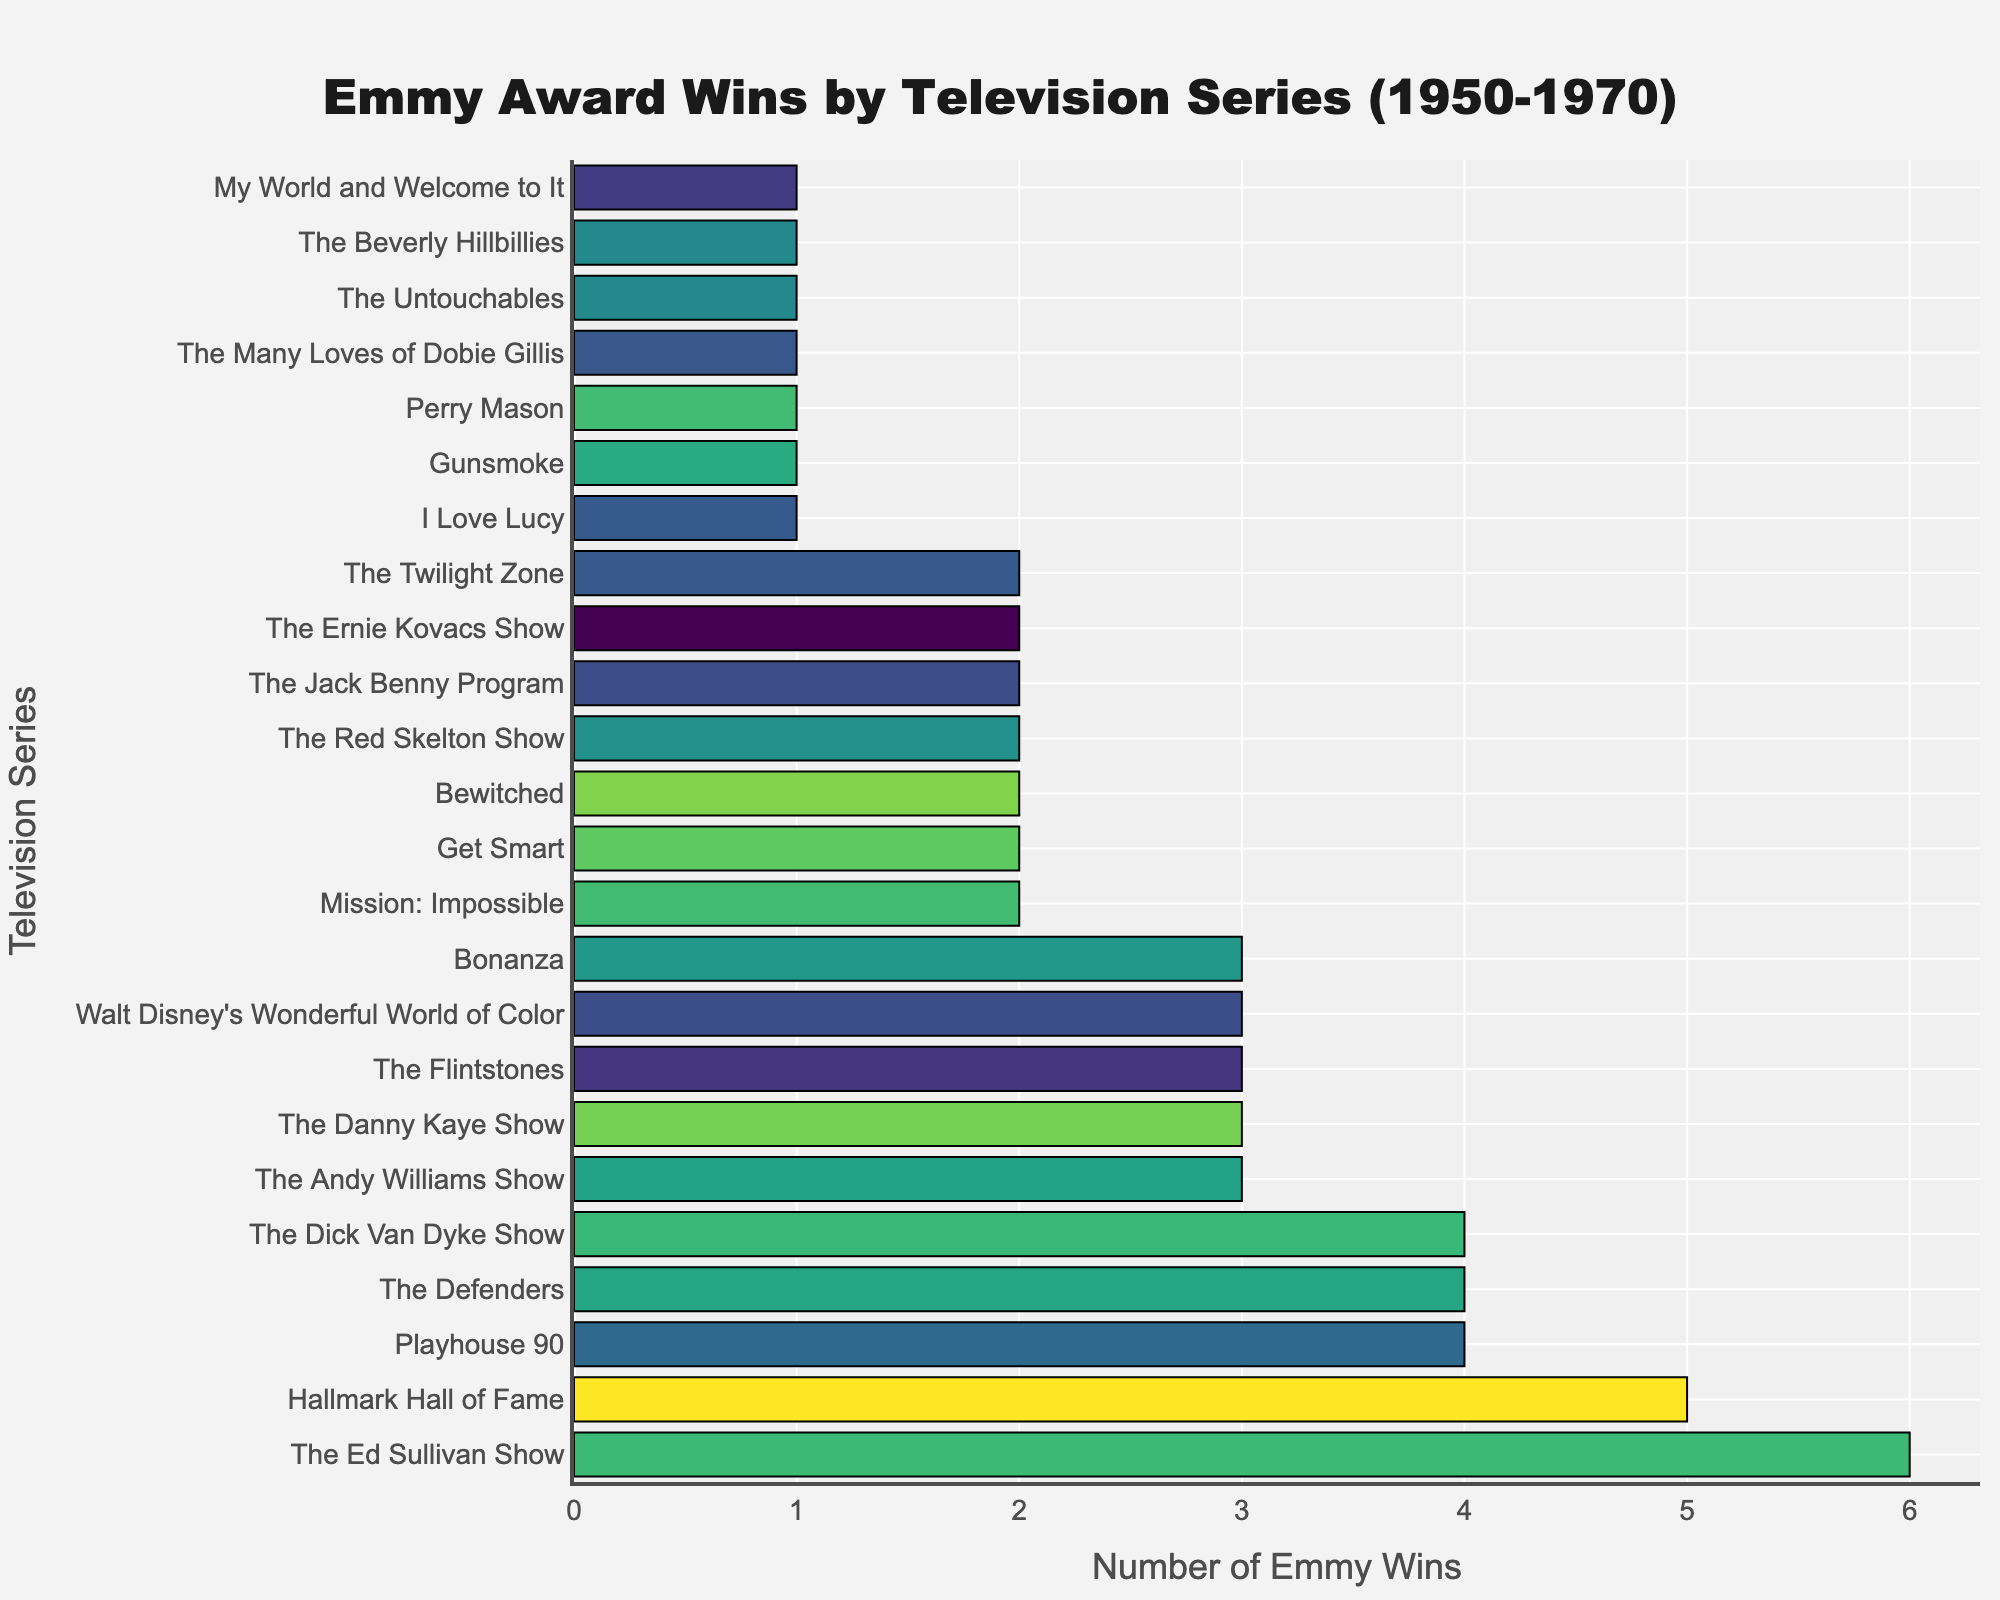Which television series has the most Emmy wins? The series is listed at the top of the bar chart with the longest bar, indicating the highest number of Emmy wins.
Answer: The Ed Sullivan Show Which two series are tied with four Emmy wins each? Locate the bars that correspond to the number four on the x-axis, then identify the labels for these bars.
Answer: Playhouse 90, The Defenders, The Dick Van Dyke Show How many series have won exactly three Emmy Awards? Count the number of bars that align with the number three on the x-axis.
Answer: 6 Which series has fewer Emmy wins: Bewitched or Perry Mason? Compare the lengths of the bars for Bewitched and Perry Mason.
Answer: Perry Mason What is the combined total of Emmy wins for The Jack Benny Program and The Red Skelton Show? The Jack Benny Program and The Red Skelton Show each have 2 Emmy wins, summed together they amount to 4.
Answer: 4 What is the difference in Emmy wins between The Ed Sullivan Show and Bonanza? The Ed Sullivan Show has 6 wins, and Bonanza has 3 wins, so the difference is 6 - 3.
Answer: 3 Which series has one Emmy win and starts with the letter 'G'? Identify the series from the bars that align with the number one and locate the one beginning with 'G'.
Answer: Gunsmoke How many more Emmy wins does The Ed Sullivan Show have compared to Get Smart? The Ed Sullivan Show has 6 wins, and Get Smart has 2 wins, so the difference is 6 - 2.
Answer: 4 What do The Twilight Zone and Mission: Impossible have in common according to the chart? Both series are represented by bars aligned with the number 2 on the x-axis.
Answer: Both won 2 Emmys What is the average number of Emmy wins for all series? Sum all the Emmy wins and divide by the number of series. (6 + 5 + 4 + 4 + 4 + 3 + 3 + 3 + 3 + 3 + 2 + 2 + 2 + 2 + 2 + 2 + 2 + 1 + 1 + 1 + 1 + 1 + 1 + 1)/24 = 2.458.
Answer: 2.46 